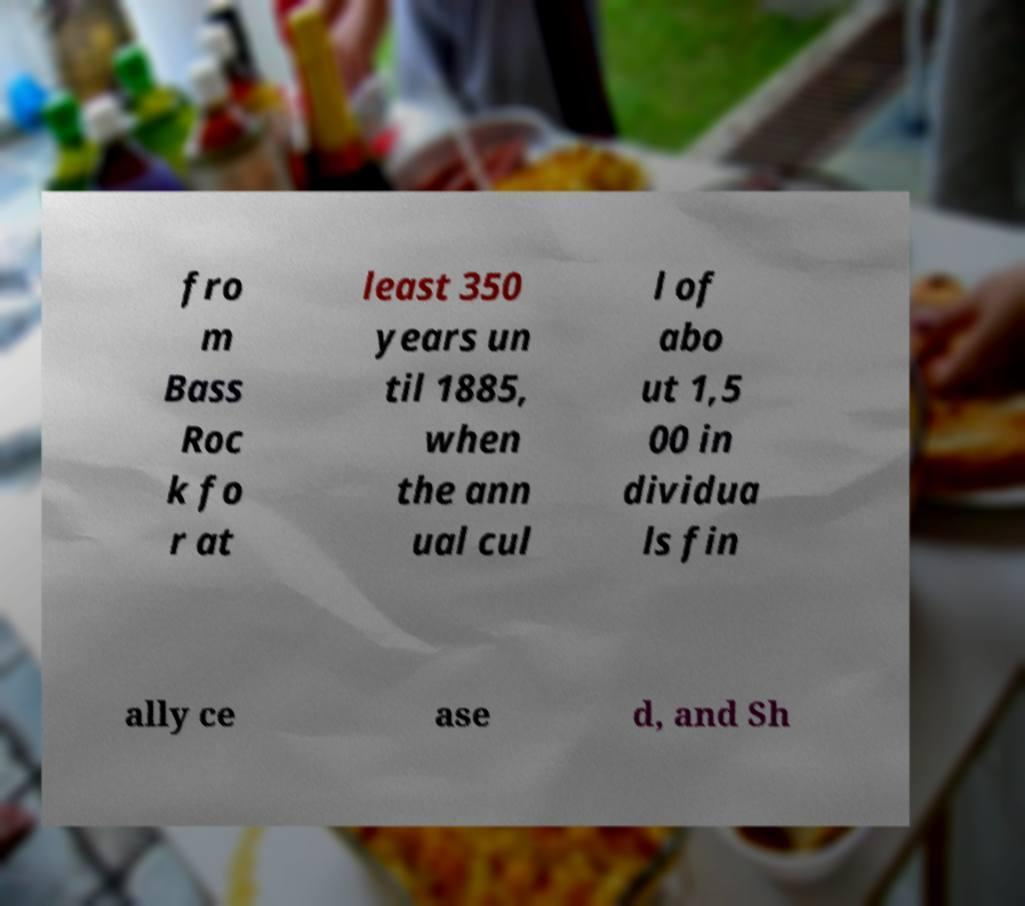For documentation purposes, I need the text within this image transcribed. Could you provide that? fro m Bass Roc k fo r at least 350 years un til 1885, when the ann ual cul l of abo ut 1,5 00 in dividua ls fin ally ce ase d, and Sh 